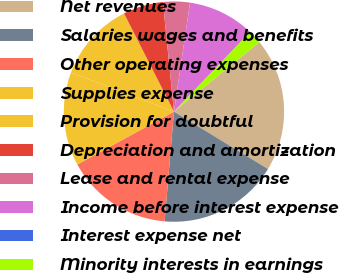Convert chart to OTSL. <chart><loc_0><loc_0><loc_500><loc_500><pie_chart><fcel>Net revenues<fcel>Salaries wages and benefits<fcel>Other operating expenses<fcel>Supplies expense<fcel>Provision for doubtful<fcel>Depreciation and amortization<fcel>Lease and rental expense<fcel>Income before interest expense<fcel>Interest expense net<fcel>Minority interests in earnings<nl><fcel>19.59%<fcel>17.63%<fcel>15.68%<fcel>13.72%<fcel>11.76%<fcel>5.89%<fcel>3.93%<fcel>9.8%<fcel>0.02%<fcel>1.98%<nl></chart> 